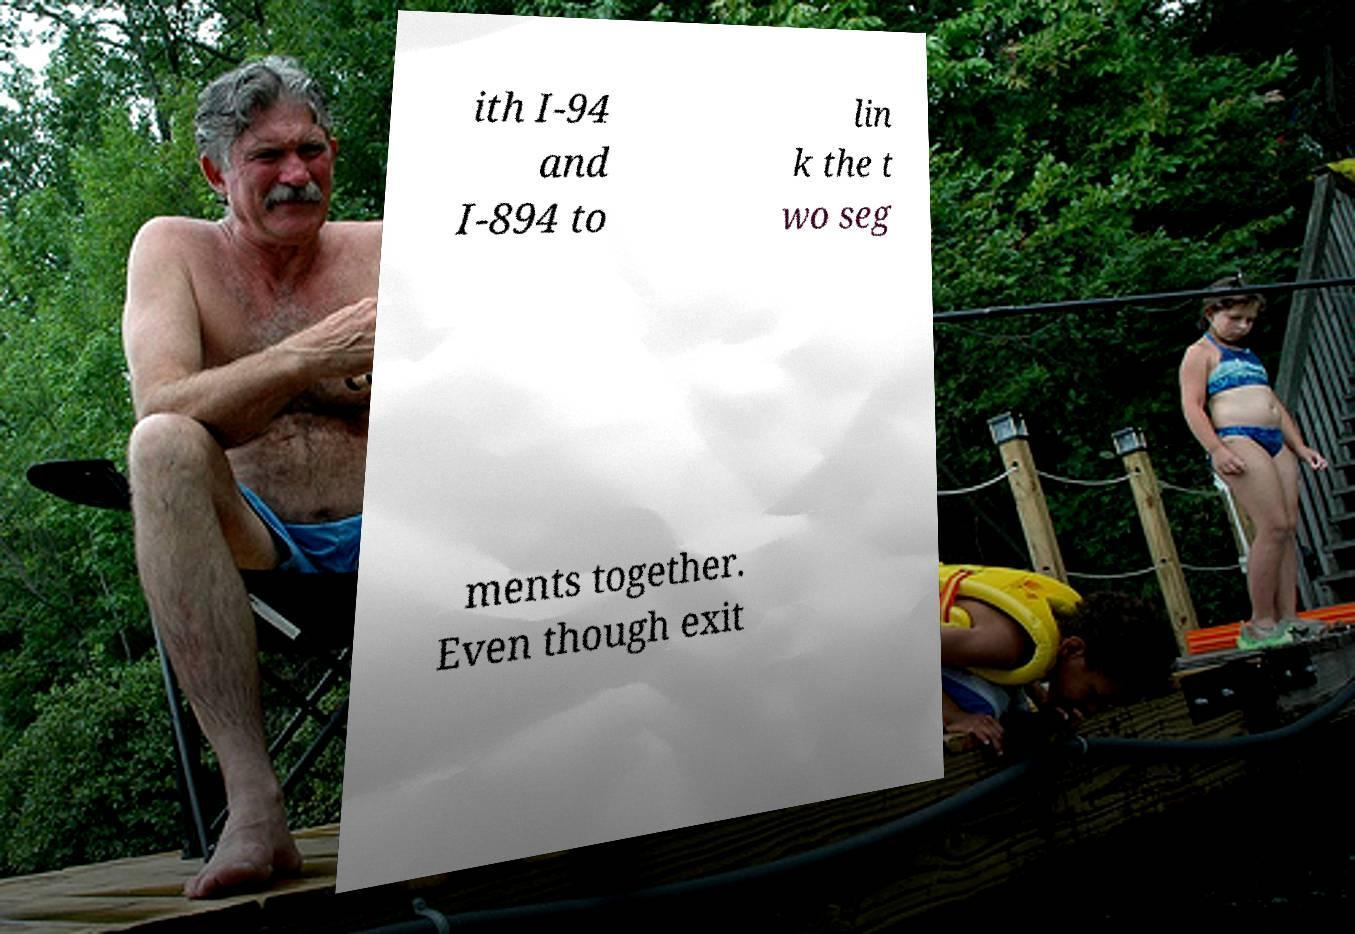For documentation purposes, I need the text within this image transcribed. Could you provide that? ith I-94 and I-894 to lin k the t wo seg ments together. Even though exit 